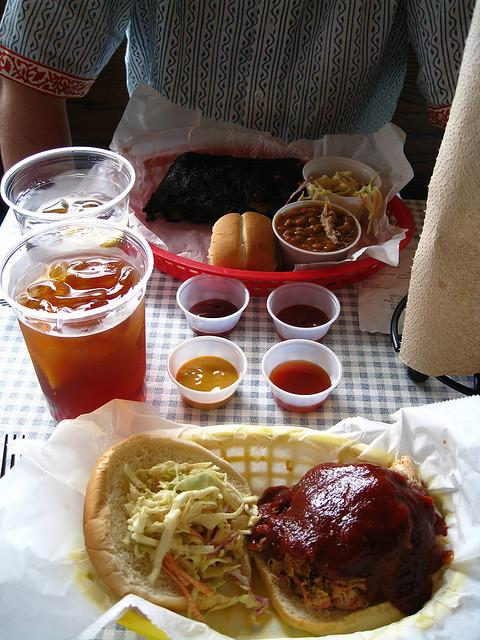What type of sandwich is being served? pulled pork 